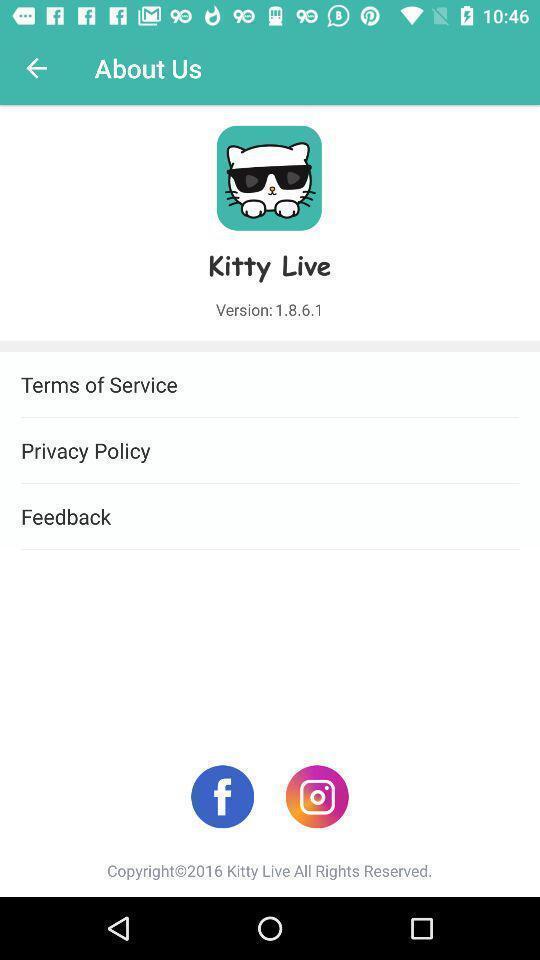Explain the elements present in this screenshot. Page showing different options about the social app. 